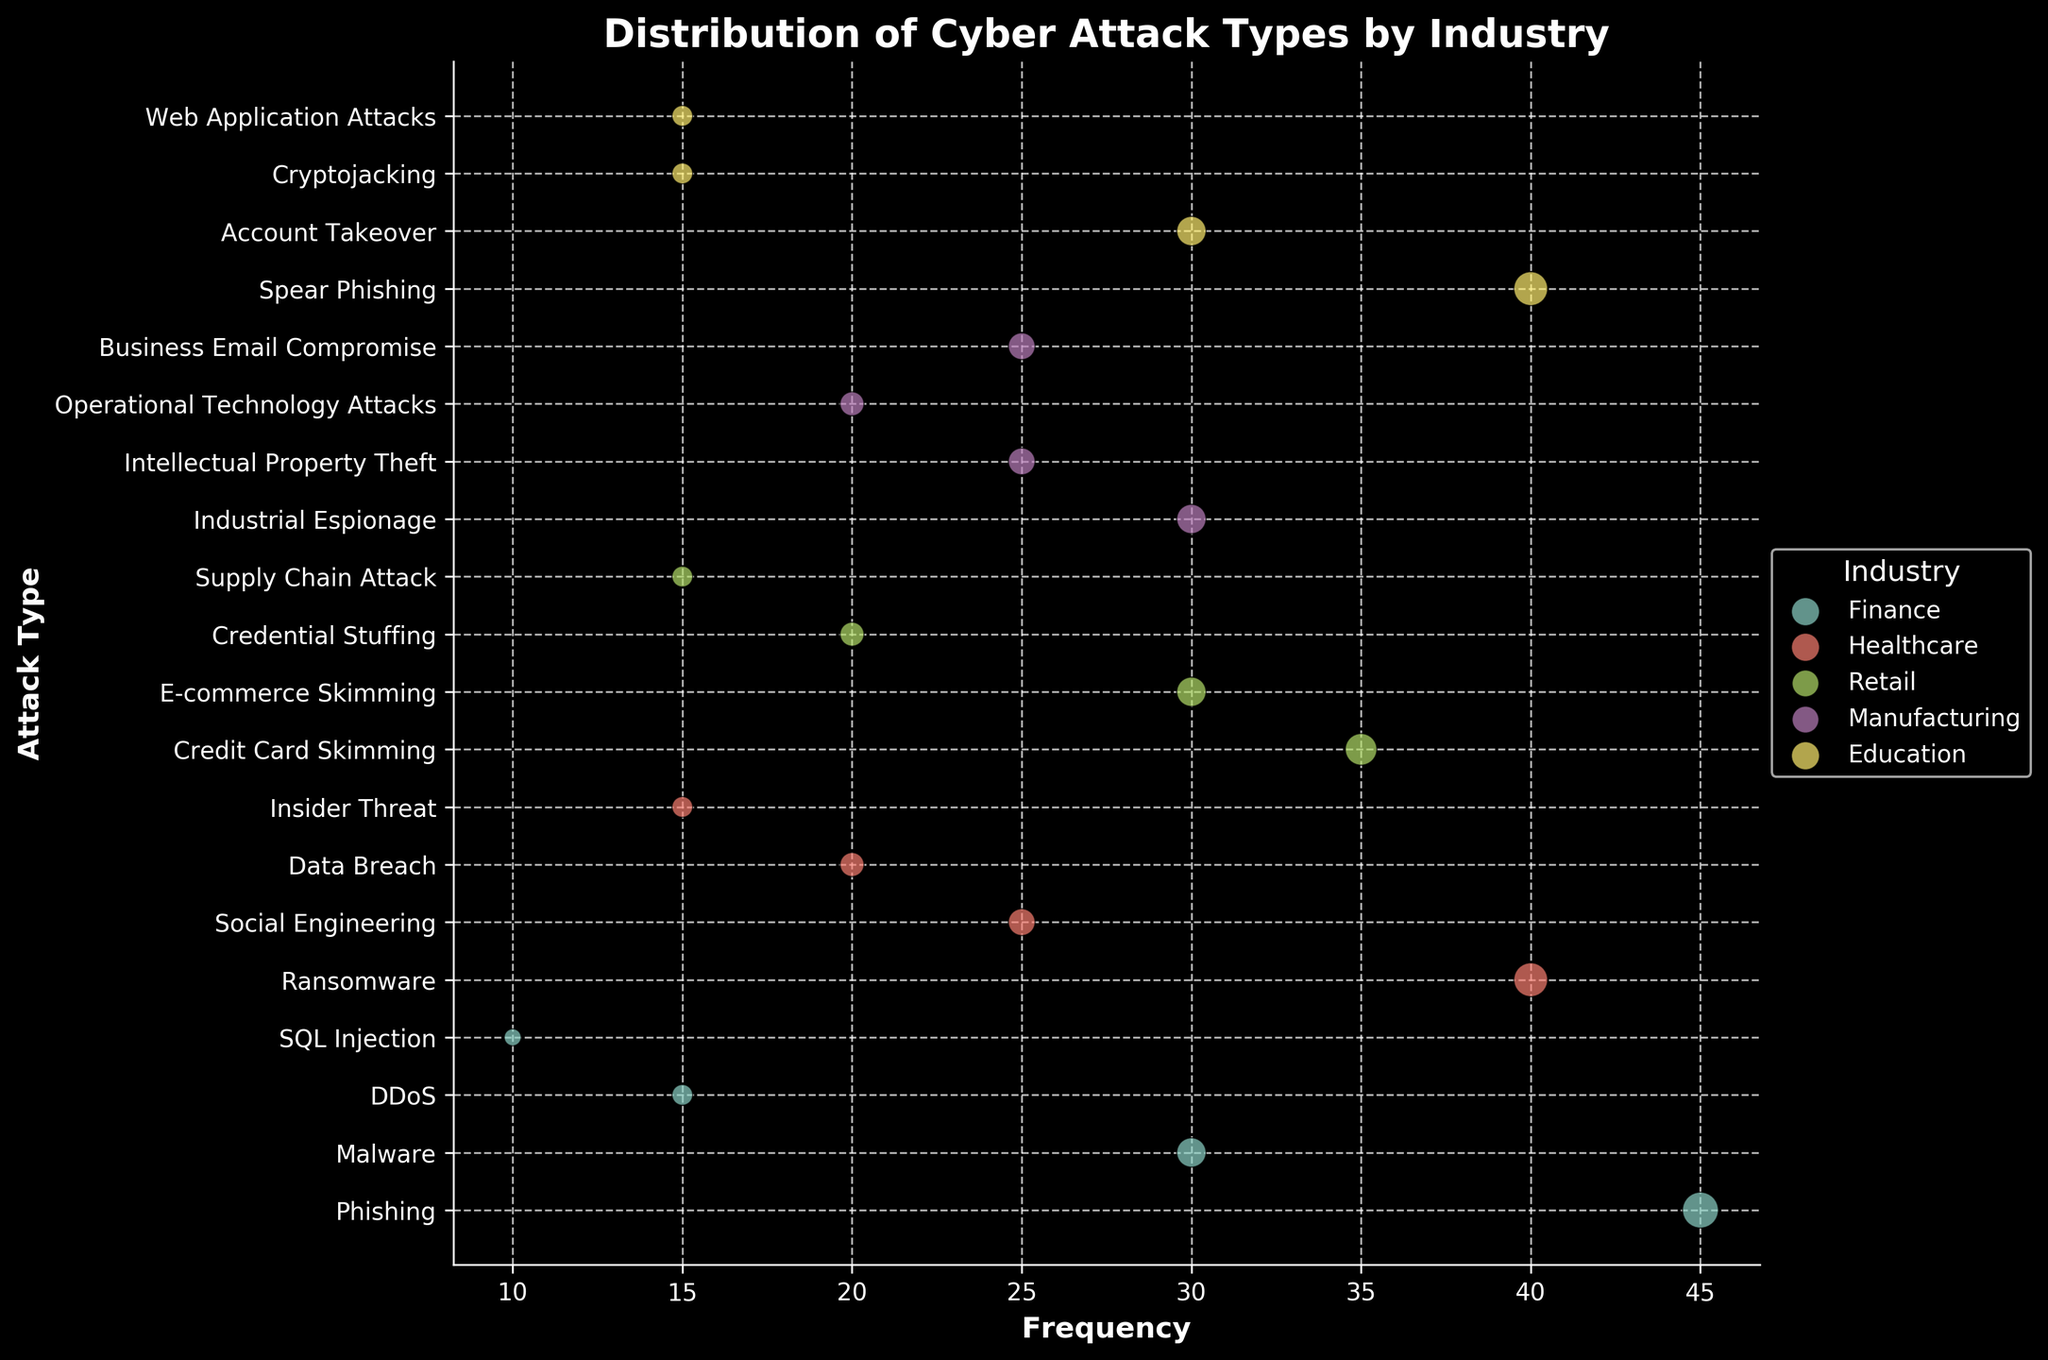What's the title of the plot? The title is prominently displayed at the top of the plot, usually in bold lettering. The plot's title is "Distribution of Cyber Attack Types by Industry".
Answer: Distribution of Cyber Attack Types by Industry Which industry experienced the highest frequency of cyber-attacks and which type was it? For the highest frequency, look at the horizontal axis for the attack type with the highest numeric value in its industry. Healthcare experienced the highest frequency of a specific cyber attack with Ransomware showing a frequency of 40.
Answer: Healthcare, Ransomware What is the common attack type in the finance industry with the second highest frequency? Identify the finance section by color and look for the second longest marker along the horizontal axis in that section aimed at the Y-axis. The attack Phishing has the highest frequency of 45, and the second highest is Malware with a frequency of 30.
Answer: Malware Compare the most frequent phishing and spear phishing attacks, which one has a higher frequency? Find the marker for phishing under Finance and Spear Phishing under Education. Phishing has a frequency of 45, while Spear Phishing has a frequency of 40.
Answer: Phishing How does the frequency of Business Email Compromise in Manufacturing compare against Credential Stuffing in Retail? Observe the scatter markers of the specified attack type among respective industries on the horizontal axis. Business Email Compromise in Manufacturing has a frequency of 25 while Credential Stuffing in Retail has a frequency of 20.
Answer: Business Email Compromise is higher How many different types of attacks are experienced in the Healthcare sector according to the plot? Count the distinct markers along the Y-axis for the healthcare industry color-coded section. There are four types: Ransomware, Social Engineering, Data Breach, and Insider Threat.
Answer: Four What is the combined frequency of SQL Injection in Finance and Web Application Attacks in Education? Locate the points in the graph for SQL Injection under Finance and Web Application Attacks under Education. Add their frequencies: 10 (SQL Injection) + 15 (Web Application Attacks) = 25.
Answer: 25 Which sector has more frequent attacks on average, Retail or Manufacturing? Calculate the average frequency of attacks in each sector. Retail: (35+30+20+15)/4 = 25. Manufacturing: (30+25+20+25)/4 = 25. Both have equal average frequency of 25.
Answer: Equal average frequency What's the least frequent attack type in the Finance sector? Identify the shortest marker along the horizontal axis in the Finance sector part of the graph. SQL Injection is the least frequent with a frequency of 10.
Answer: SQL Injection What's the total frequency of all specified attacks in the Education sector? Sum the frequencies of all attack types in Education. 40 (Spear Phishing) + 30 (Account Takeover) + 15 (Cryptojacking) + 15 (Web Application Attacks) = 100.
Answer: 100 